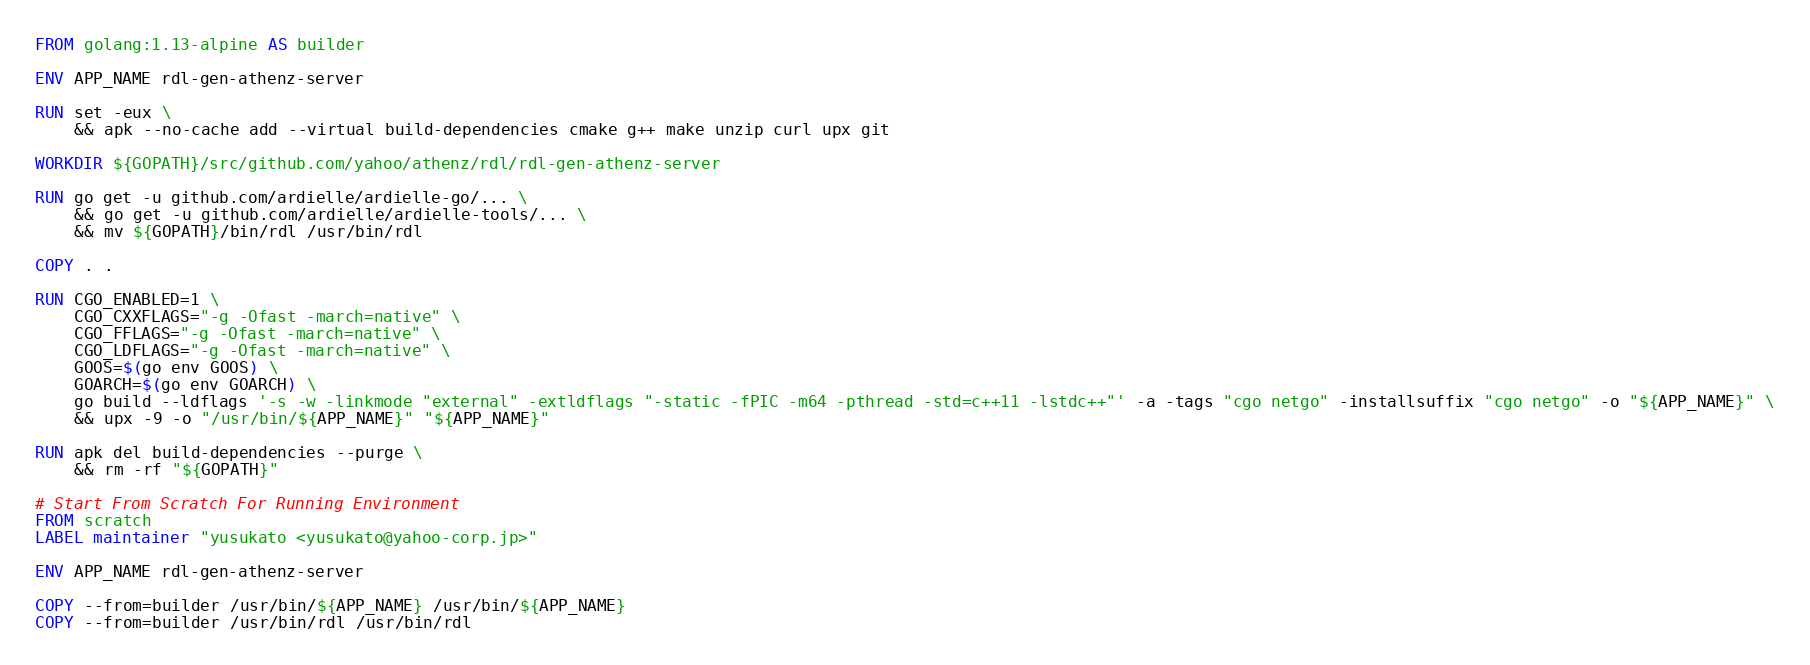Convert code to text. <code><loc_0><loc_0><loc_500><loc_500><_Dockerfile_>FROM golang:1.13-alpine AS builder

ENV APP_NAME rdl-gen-athenz-server

RUN set -eux \
    && apk --no-cache add --virtual build-dependencies cmake g++ make unzip curl upx git

WORKDIR ${GOPATH}/src/github.com/yahoo/athenz/rdl/rdl-gen-athenz-server

RUN go get -u github.com/ardielle/ardielle-go/... \
    && go get -u github.com/ardielle/ardielle-tools/... \
    && mv ${GOPATH}/bin/rdl /usr/bin/rdl

COPY . .

RUN CGO_ENABLED=1 \
    CGO_CXXFLAGS="-g -Ofast -march=native" \
    CGO_FFLAGS="-g -Ofast -march=native" \
    CGO_LDFLAGS="-g -Ofast -march=native" \
    GOOS=$(go env GOOS) \
    GOARCH=$(go env GOARCH) \
    go build --ldflags '-s -w -linkmode "external" -extldflags "-static -fPIC -m64 -pthread -std=c++11 -lstdc++"' -a -tags "cgo netgo" -installsuffix "cgo netgo" -o "${APP_NAME}" \
    && upx -9 -o "/usr/bin/${APP_NAME}" "${APP_NAME}"

RUN apk del build-dependencies --purge \
    && rm -rf "${GOPATH}"

# Start From Scratch For Running Environment
FROM scratch
LABEL maintainer "yusukato <yusukato@yahoo-corp.jp>"

ENV APP_NAME rdl-gen-athenz-server

COPY --from=builder /usr/bin/${APP_NAME} /usr/bin/${APP_NAME}
COPY --from=builder /usr/bin/rdl /usr/bin/rdl
</code> 